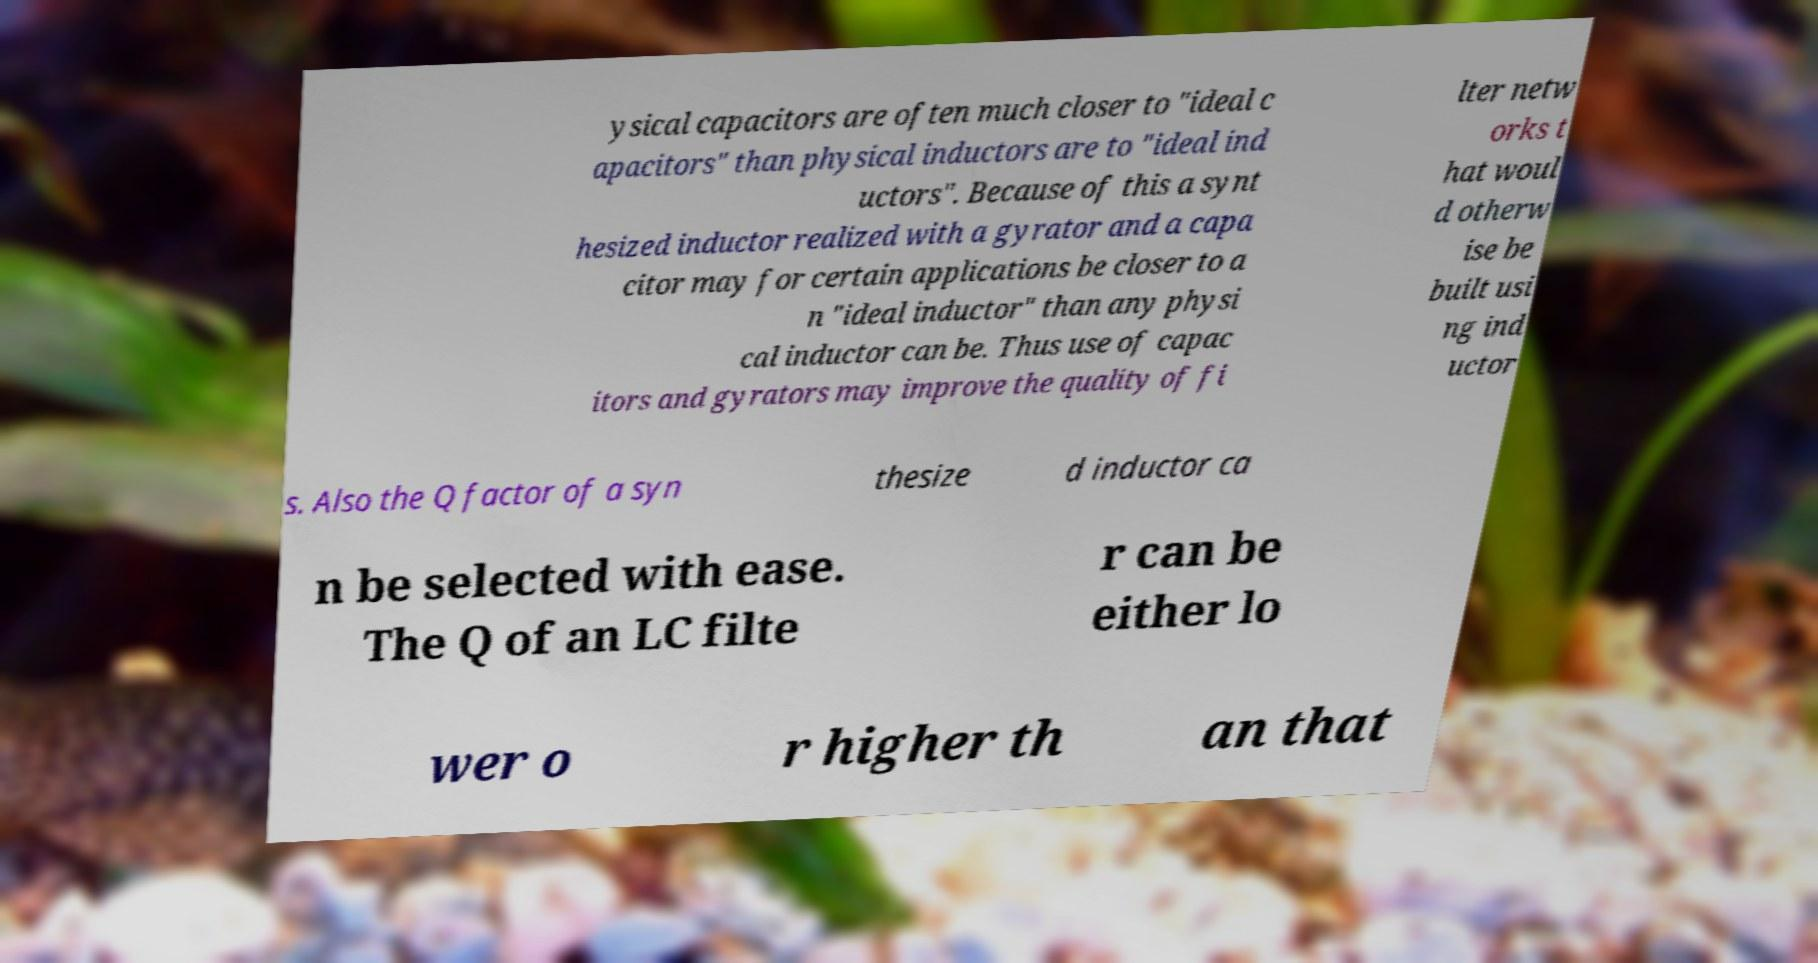What messages or text are displayed in this image? I need them in a readable, typed format. ysical capacitors are often much closer to "ideal c apacitors" than physical inductors are to "ideal ind uctors". Because of this a synt hesized inductor realized with a gyrator and a capa citor may for certain applications be closer to a n "ideal inductor" than any physi cal inductor can be. Thus use of capac itors and gyrators may improve the quality of fi lter netw orks t hat woul d otherw ise be built usi ng ind uctor s. Also the Q factor of a syn thesize d inductor ca n be selected with ease. The Q of an LC filte r can be either lo wer o r higher th an that 